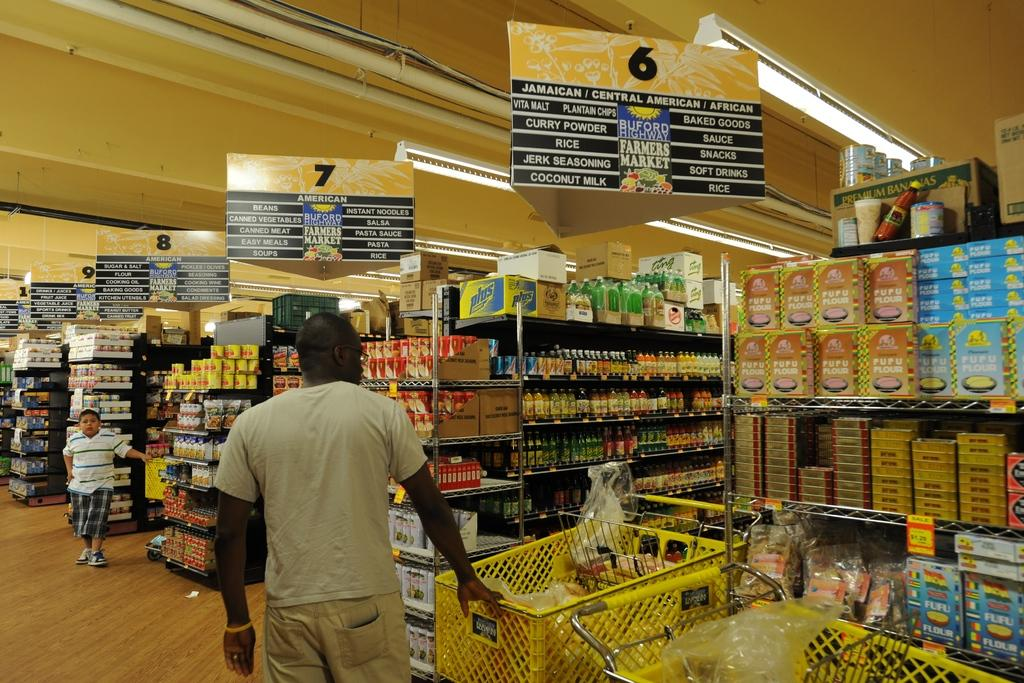Provide a one-sentence caption for the provided image. A person with a shopping cart is in the front of isle 6. 